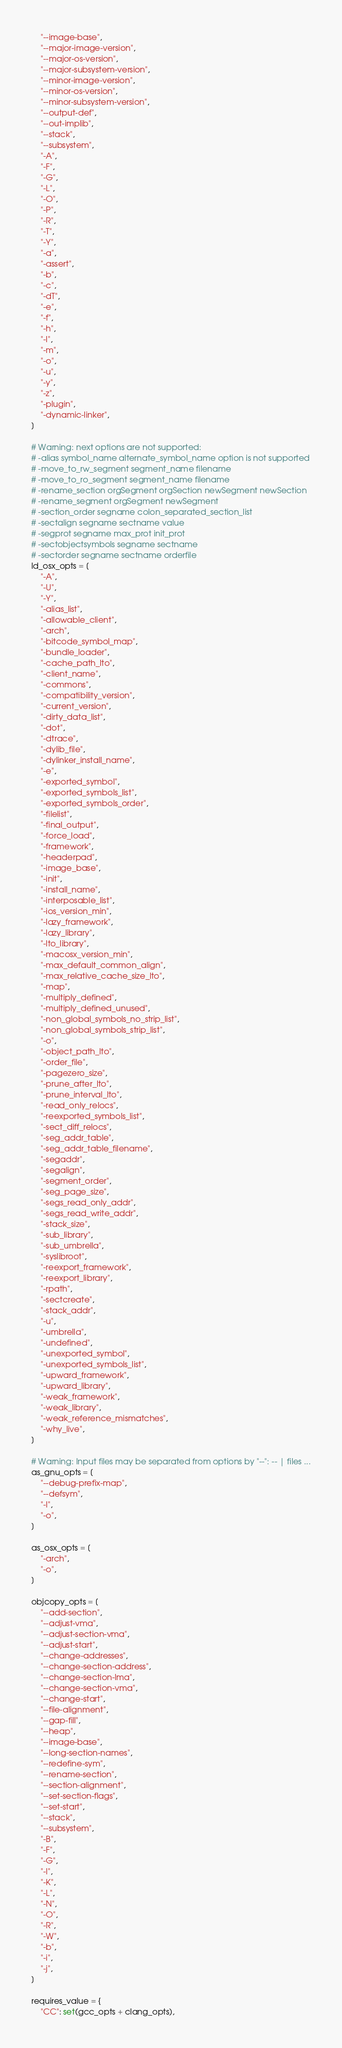Convert code to text. <code><loc_0><loc_0><loc_500><loc_500><_Python_>    "--image-base",
    "--major-image-version",
    "--major-os-version",
    "--major-subsystem-version",
    "--minor-image-version",
    "--minor-os-version",
    "--minor-subsystem-version",
    "--output-def",
    "--out-implib",
    "--stack",
    "--subsystem",
    "-A",
    "-F",
    "-G",
    "-L",
    "-O",
    "-P",
    "-R",
    "-T",
    "-Y",
    "-a",
    "-assert",
    "-b",
    "-c",
    "-dT",
    "-e",
    "-f",
    "-h",
    "-l",
    "-m",
    "-o",
    "-u",
    "-y",
    "-z",
    "-plugin",
    "-dynamic-linker",
]

# Warning: next options are not supported:
# -alias symbol_name alternate_symbol_name option is not supported
# -move_to_rw_segment segment_name filename
# -move_to_ro_segment segment_name filename
# -rename_section orgSegment orgSection newSegment newSection
# -rename_segment orgSegment newSegment
# -section_order segname colon_separated_section_list
# -sectalign segname sectname value
# -segprot segname max_prot init_prot
# -sectobjectsymbols segname sectname
# -sectorder segname sectname orderfile
ld_osx_opts = [
    "-A",
    "-U",
    "-Y",
    "-alias_list",
    "-allowable_client",
    "-arch",
    "-bitcode_symbol_map",
    "-bundle_loader",
    "-cache_path_lto",
    "-client_name",
    "-commons",
    "-compatibility_version",
    "-current_version",
    "-dirty_data_list",
    "-dot",
    "-dtrace",
    "-dylib_file",
    "-dylinker_install_name",
    "-e",
    "-exported_symbol",
    "-exported_symbols_list",
    "-exported_symbols_order",
    "-filelist",
    "-final_output",
    "-force_load",
    "-framework",
    "-headerpad",
    "-image_base",
    "-init",
    "-install_name",
    "-interposable_list",
    "-ios_version_min",
    "-lazy_framework",
    "-lazy_library",
    "-lto_library",
    "-macosx_version_min",
    "-max_default_common_align",
    "-max_relative_cache_size_lto",
    "-map",
    "-multiply_defined",
    "-multiply_defined_unused",
    "-non_global_symbols_no_strip_list",
    "-non_global_symbols_strip_list",
    "-o",
    "-object_path_lto",
    "-order_file",
    "-pagezero_size",
    "-prune_after_lto",
    "-prune_interval_lto",
    "-read_only_relocs",
    "-reexported_symbols_list",
    "-sect_diff_relocs",
    "-seg_addr_table",
    "-seg_addr_table_filename",
    "-segaddr",
    "-segalign",
    "-segment_order",
    "-seg_page_size",
    "-segs_read_only_addr",
    "-segs_read_write_addr",
    "-stack_size",
    "-sub_library",
    "-sub_umbrella",
    "-syslibroot",
    "-reexport_framework",
    "-reexport_library",
    "-rpath",
    "-sectcreate",
    "-stack_addr",
    "-u",
    "-umbrella",
    "-undefined",
    "-unexported_symbol",
    "-unexported_symbols_list",
    "-upward_framework",
    "-upward_library",
    "-weak_framework",
    "-weak_library",
    "-weak_reference_mismatches",
    "-why_live",
]

# Warning: Input files may be separated from options by "--": -- | files ...
as_gnu_opts = [
    "--debug-prefix-map",
    "--defsym",
    "-I",
    "-o",
]

as_osx_opts = [
    "-arch",
    "-o",
]

objcopy_opts = [
    "--add-section",
    "--adjust-vma",
    "--adjust-section-vma",
    "--adjust-start",
    "--change-addresses",
    "--change-section-address",
    "--change-section-lma",
    "--change-section-vma",
    "--change-start",
    "--file-alignment",
    "--gap-fill",
    "--heap",
    "--image-base",
    "--long-section-names",
    "--redefine-sym",
    "--rename-section",
    "--section-alignment",
    "--set-section-flags",
    "--set-start",
    "--stack",
    "--subsystem",
    "-B",
    "-F",
    "-G",
    "-I",
    "-K",
    "-L",
    "-N",
    "-O",
    "-R",
    "-W",
    "-b",
    "-i",
    "-j",
]

requires_value = {
    "CC": set(gcc_opts + clang_opts),</code> 